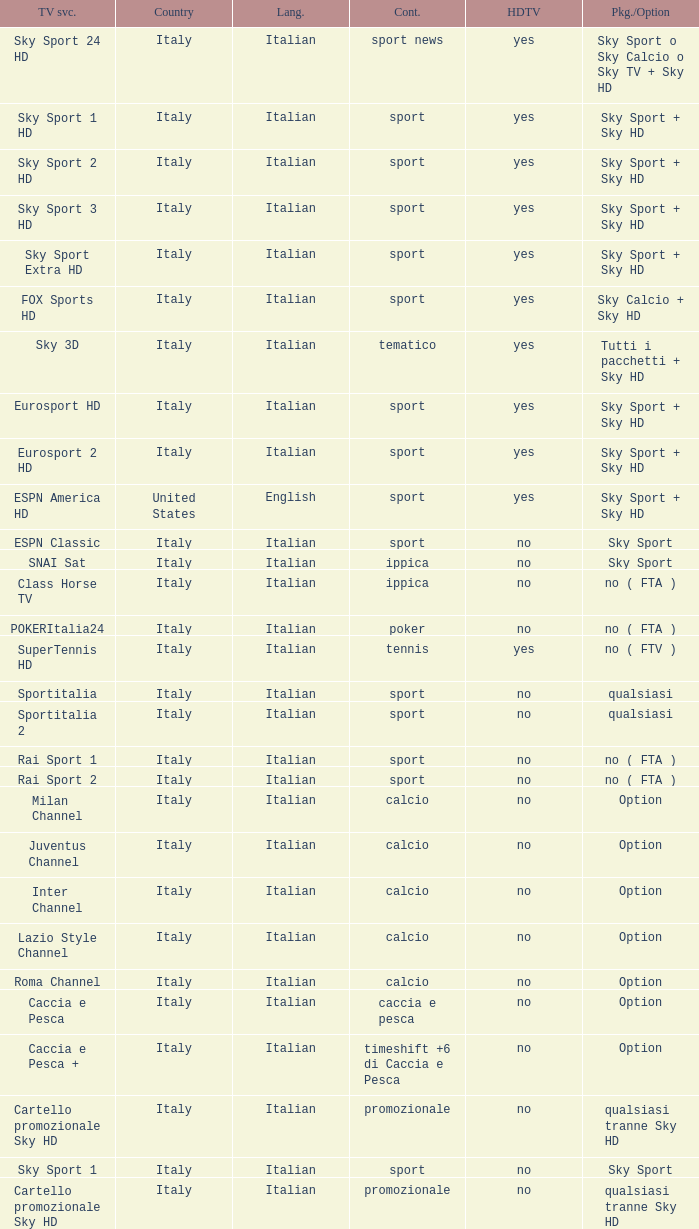What is Country, when Television Service is Eurosport 2? Italy. Help me parse the entirety of this table. {'header': ['TV svc.', 'Country', 'Lang.', 'Cont.', 'HDTV', 'Pkg./Option'], 'rows': [['Sky Sport 24 HD', 'Italy', 'Italian', 'sport news', 'yes', 'Sky Sport o Sky Calcio o Sky TV + Sky HD'], ['Sky Sport 1 HD', 'Italy', 'Italian', 'sport', 'yes', 'Sky Sport + Sky HD'], ['Sky Sport 2 HD', 'Italy', 'Italian', 'sport', 'yes', 'Sky Sport + Sky HD'], ['Sky Sport 3 HD', 'Italy', 'Italian', 'sport', 'yes', 'Sky Sport + Sky HD'], ['Sky Sport Extra HD', 'Italy', 'Italian', 'sport', 'yes', 'Sky Sport + Sky HD'], ['FOX Sports HD', 'Italy', 'Italian', 'sport', 'yes', 'Sky Calcio + Sky HD'], ['Sky 3D', 'Italy', 'Italian', 'tematico', 'yes', 'Tutti i pacchetti + Sky HD'], ['Eurosport HD', 'Italy', 'Italian', 'sport', 'yes', 'Sky Sport + Sky HD'], ['Eurosport 2 HD', 'Italy', 'Italian', 'sport', 'yes', 'Sky Sport + Sky HD'], ['ESPN America HD', 'United States', 'English', 'sport', 'yes', 'Sky Sport + Sky HD'], ['ESPN Classic', 'Italy', 'Italian', 'sport', 'no', 'Sky Sport'], ['SNAI Sat', 'Italy', 'Italian', 'ippica', 'no', 'Sky Sport'], ['Class Horse TV', 'Italy', 'Italian', 'ippica', 'no', 'no ( FTA )'], ['POKERItalia24', 'Italy', 'Italian', 'poker', 'no', 'no ( FTA )'], ['SuperTennis HD', 'Italy', 'Italian', 'tennis', 'yes', 'no ( FTV )'], ['Sportitalia', 'Italy', 'Italian', 'sport', 'no', 'qualsiasi'], ['Sportitalia 2', 'Italy', 'Italian', 'sport', 'no', 'qualsiasi'], ['Rai Sport 1', 'Italy', 'Italian', 'sport', 'no', 'no ( FTA )'], ['Rai Sport 2', 'Italy', 'Italian', 'sport', 'no', 'no ( FTA )'], ['Milan Channel', 'Italy', 'Italian', 'calcio', 'no', 'Option'], ['Juventus Channel', 'Italy', 'Italian', 'calcio', 'no', 'Option'], ['Inter Channel', 'Italy', 'Italian', 'calcio', 'no', 'Option'], ['Lazio Style Channel', 'Italy', 'Italian', 'calcio', 'no', 'Option'], ['Roma Channel', 'Italy', 'Italian', 'calcio', 'no', 'Option'], ['Caccia e Pesca', 'Italy', 'Italian', 'caccia e pesca', 'no', 'Option'], ['Caccia e Pesca +', 'Italy', 'Italian', 'timeshift +6 di Caccia e Pesca', 'no', 'Option'], ['Cartello promozionale Sky HD', 'Italy', 'Italian', 'promozionale', 'no', 'qualsiasi tranne Sky HD'], ['Sky Sport 1', 'Italy', 'Italian', 'sport', 'no', 'Sky Sport'], ['Cartello promozionale Sky HD', 'Italy', 'Italian', 'promozionale', 'no', 'qualsiasi tranne Sky HD'], ['Sky Sport 2', 'Italy', 'Italian', 'sport', 'no', 'Sky Sport'], ['Cartello promozionale Sky HD', 'Italy', 'Italian', 'promozionale', 'no', 'qualsiasi tranne Sky HD'], ['Sky Sport 3', 'Italy', 'Italian', 'sport', 'no', 'Sky Sport'], ['Cartello promozionale Sky HD', 'Italy', 'Italian', 'promozionale', 'no', 'qualsiasi tranne Sky HD'], ['Sky Sport Extra', 'Italy', 'Italian', 'sport', 'no', 'Sky Sport'], ['Cartello promozionale Sky HD', 'Italy', 'Italian', 'promozionale', 'no', 'qualsiasi tranne Sky HD'], ['Sky Supercalcio', 'Italy', 'Italian', 'calcio', 'no', 'Sky Calcio'], ['Cartello promozionale Sky HD', 'Italy', 'Italian', 'promozionale', 'no', 'qualsiasi tranne Sky HD'], ['Eurosport', 'Italy', 'Italian', 'sport', 'no', 'Sky Sport'], ['Eurosport 2', 'Italy', 'Italian', 'sport', 'no', 'Sky Sport'], ['ESPN America', 'Italy', 'Italian', 'sport', 'no', 'Sky Sport']]} 